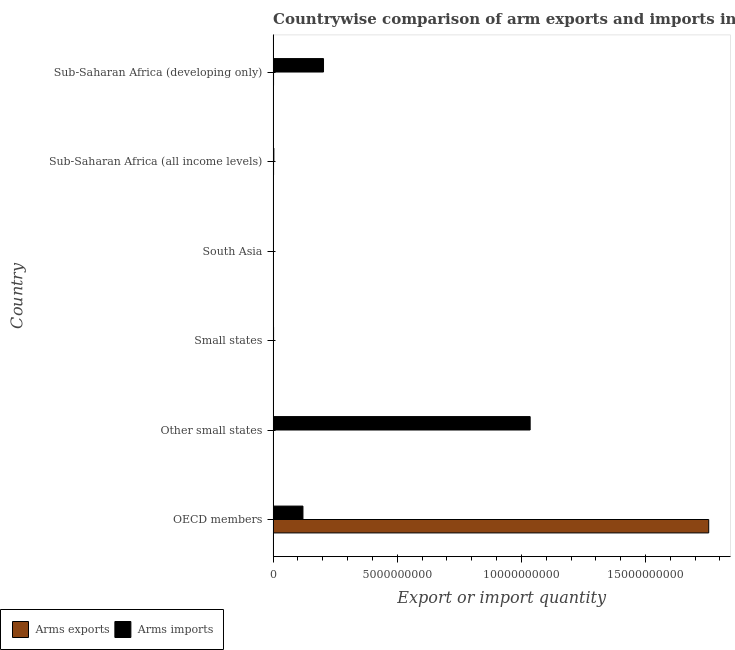How many groups of bars are there?
Your answer should be compact. 6. Are the number of bars per tick equal to the number of legend labels?
Your answer should be very brief. Yes. What is the label of the 1st group of bars from the top?
Make the answer very short. Sub-Saharan Africa (developing only). In how many cases, is the number of bars for a given country not equal to the number of legend labels?
Provide a short and direct response. 0. What is the arms exports in Sub-Saharan Africa (developing only)?
Your answer should be very brief. 1.70e+07. Across all countries, what is the maximum arms exports?
Ensure brevity in your answer.  1.75e+1. Across all countries, what is the minimum arms exports?
Offer a very short reply. 1.00e+06. In which country was the arms exports maximum?
Give a very brief answer. OECD members. In which country was the arms exports minimum?
Your response must be concise. Other small states. What is the total arms imports in the graph?
Offer a very short reply. 1.36e+1. What is the difference between the arms imports in Other small states and that in South Asia?
Your answer should be very brief. 1.03e+1. What is the difference between the arms imports in Small states and the arms exports in Other small states?
Your answer should be very brief. 1.70e+07. What is the average arms exports per country?
Offer a terse response. 2.93e+09. What is the difference between the arms imports and arms exports in Other small states?
Your answer should be compact. 1.04e+1. What is the ratio of the arms exports in South Asia to that in Sub-Saharan Africa (developing only)?
Keep it short and to the point. 0.12. What is the difference between the highest and the second highest arms exports?
Your response must be concise. 1.75e+1. What is the difference between the highest and the lowest arms exports?
Provide a short and direct response. 1.75e+1. In how many countries, is the arms imports greater than the average arms imports taken over all countries?
Offer a terse response. 1. Is the sum of the arms imports in Small states and South Asia greater than the maximum arms exports across all countries?
Offer a terse response. No. What does the 1st bar from the top in Small states represents?
Your response must be concise. Arms imports. What does the 1st bar from the bottom in OECD members represents?
Your response must be concise. Arms exports. How many bars are there?
Keep it short and to the point. 12. How many countries are there in the graph?
Keep it short and to the point. 6. Are the values on the major ticks of X-axis written in scientific E-notation?
Your answer should be very brief. No. What is the title of the graph?
Give a very brief answer. Countrywise comparison of arm exports and imports in 1995. Does "Merchandise imports" appear as one of the legend labels in the graph?
Make the answer very short. No. What is the label or title of the X-axis?
Offer a terse response. Export or import quantity. What is the label or title of the Y-axis?
Give a very brief answer. Country. What is the Export or import quantity in Arms exports in OECD members?
Your response must be concise. 1.75e+1. What is the Export or import quantity of Arms imports in OECD members?
Make the answer very short. 1.20e+09. What is the Export or import quantity in Arms imports in Other small states?
Your answer should be compact. 1.04e+1. What is the Export or import quantity of Arms imports in Small states?
Your answer should be very brief. 1.80e+07. What is the Export or import quantity in Arms imports in South Asia?
Your answer should be very brief. 1.20e+07. What is the Export or import quantity in Arms exports in Sub-Saharan Africa (all income levels)?
Ensure brevity in your answer.  1.80e+07. What is the Export or import quantity of Arms imports in Sub-Saharan Africa (all income levels)?
Provide a succinct answer. 3.00e+07. What is the Export or import quantity of Arms exports in Sub-Saharan Africa (developing only)?
Offer a terse response. 1.70e+07. What is the Export or import quantity of Arms imports in Sub-Saharan Africa (developing only)?
Your answer should be very brief. 2.03e+09. Across all countries, what is the maximum Export or import quantity in Arms exports?
Your answer should be very brief. 1.75e+1. Across all countries, what is the maximum Export or import quantity in Arms imports?
Your answer should be very brief. 1.04e+1. What is the total Export or import quantity of Arms exports in the graph?
Keep it short and to the point. 1.76e+1. What is the total Export or import quantity of Arms imports in the graph?
Your answer should be compact. 1.36e+1. What is the difference between the Export or import quantity in Arms exports in OECD members and that in Other small states?
Provide a short and direct response. 1.75e+1. What is the difference between the Export or import quantity of Arms imports in OECD members and that in Other small states?
Provide a succinct answer. -9.15e+09. What is the difference between the Export or import quantity in Arms exports in OECD members and that in Small states?
Your response must be concise. 1.75e+1. What is the difference between the Export or import quantity of Arms imports in OECD members and that in Small states?
Provide a short and direct response. 1.18e+09. What is the difference between the Export or import quantity of Arms exports in OECD members and that in South Asia?
Your answer should be very brief. 1.75e+1. What is the difference between the Export or import quantity in Arms imports in OECD members and that in South Asia?
Your response must be concise. 1.19e+09. What is the difference between the Export or import quantity of Arms exports in OECD members and that in Sub-Saharan Africa (all income levels)?
Keep it short and to the point. 1.75e+1. What is the difference between the Export or import quantity of Arms imports in OECD members and that in Sub-Saharan Africa (all income levels)?
Provide a succinct answer. 1.17e+09. What is the difference between the Export or import quantity in Arms exports in OECD members and that in Sub-Saharan Africa (developing only)?
Your response must be concise. 1.75e+1. What is the difference between the Export or import quantity of Arms imports in OECD members and that in Sub-Saharan Africa (developing only)?
Your response must be concise. -8.28e+08. What is the difference between the Export or import quantity in Arms imports in Other small states and that in Small states?
Keep it short and to the point. 1.03e+1. What is the difference between the Export or import quantity of Arms exports in Other small states and that in South Asia?
Your answer should be very brief. -1.00e+06. What is the difference between the Export or import quantity of Arms imports in Other small states and that in South Asia?
Make the answer very short. 1.03e+1. What is the difference between the Export or import quantity of Arms exports in Other small states and that in Sub-Saharan Africa (all income levels)?
Provide a short and direct response. -1.70e+07. What is the difference between the Export or import quantity in Arms imports in Other small states and that in Sub-Saharan Africa (all income levels)?
Your answer should be very brief. 1.03e+1. What is the difference between the Export or import quantity in Arms exports in Other small states and that in Sub-Saharan Africa (developing only)?
Offer a terse response. -1.60e+07. What is the difference between the Export or import quantity of Arms imports in Other small states and that in Sub-Saharan Africa (developing only)?
Provide a succinct answer. 8.32e+09. What is the difference between the Export or import quantity of Arms exports in Small states and that in South Asia?
Provide a short and direct response. -1.00e+06. What is the difference between the Export or import quantity in Arms exports in Small states and that in Sub-Saharan Africa (all income levels)?
Ensure brevity in your answer.  -1.70e+07. What is the difference between the Export or import quantity in Arms imports in Small states and that in Sub-Saharan Africa (all income levels)?
Make the answer very short. -1.20e+07. What is the difference between the Export or import quantity of Arms exports in Small states and that in Sub-Saharan Africa (developing only)?
Your answer should be very brief. -1.60e+07. What is the difference between the Export or import quantity of Arms imports in Small states and that in Sub-Saharan Africa (developing only)?
Give a very brief answer. -2.01e+09. What is the difference between the Export or import quantity in Arms exports in South Asia and that in Sub-Saharan Africa (all income levels)?
Ensure brevity in your answer.  -1.60e+07. What is the difference between the Export or import quantity of Arms imports in South Asia and that in Sub-Saharan Africa (all income levels)?
Your response must be concise. -1.80e+07. What is the difference between the Export or import quantity in Arms exports in South Asia and that in Sub-Saharan Africa (developing only)?
Offer a very short reply. -1.50e+07. What is the difference between the Export or import quantity of Arms imports in South Asia and that in Sub-Saharan Africa (developing only)?
Your answer should be very brief. -2.02e+09. What is the difference between the Export or import quantity of Arms exports in Sub-Saharan Africa (all income levels) and that in Sub-Saharan Africa (developing only)?
Ensure brevity in your answer.  1.00e+06. What is the difference between the Export or import quantity in Arms imports in Sub-Saharan Africa (all income levels) and that in Sub-Saharan Africa (developing only)?
Give a very brief answer. -2.00e+09. What is the difference between the Export or import quantity of Arms exports in OECD members and the Export or import quantity of Arms imports in Other small states?
Give a very brief answer. 7.19e+09. What is the difference between the Export or import quantity in Arms exports in OECD members and the Export or import quantity in Arms imports in Small states?
Make the answer very short. 1.75e+1. What is the difference between the Export or import quantity in Arms exports in OECD members and the Export or import quantity in Arms imports in South Asia?
Make the answer very short. 1.75e+1. What is the difference between the Export or import quantity of Arms exports in OECD members and the Export or import quantity of Arms imports in Sub-Saharan Africa (all income levels)?
Offer a terse response. 1.75e+1. What is the difference between the Export or import quantity of Arms exports in OECD members and the Export or import quantity of Arms imports in Sub-Saharan Africa (developing only)?
Your response must be concise. 1.55e+1. What is the difference between the Export or import quantity of Arms exports in Other small states and the Export or import quantity of Arms imports in Small states?
Provide a succinct answer. -1.70e+07. What is the difference between the Export or import quantity in Arms exports in Other small states and the Export or import quantity in Arms imports in South Asia?
Provide a succinct answer. -1.10e+07. What is the difference between the Export or import quantity of Arms exports in Other small states and the Export or import quantity of Arms imports in Sub-Saharan Africa (all income levels)?
Make the answer very short. -2.90e+07. What is the difference between the Export or import quantity of Arms exports in Other small states and the Export or import quantity of Arms imports in Sub-Saharan Africa (developing only)?
Provide a short and direct response. -2.03e+09. What is the difference between the Export or import quantity in Arms exports in Small states and the Export or import quantity in Arms imports in South Asia?
Your answer should be very brief. -1.10e+07. What is the difference between the Export or import quantity in Arms exports in Small states and the Export or import quantity in Arms imports in Sub-Saharan Africa (all income levels)?
Make the answer very short. -2.90e+07. What is the difference between the Export or import quantity of Arms exports in Small states and the Export or import quantity of Arms imports in Sub-Saharan Africa (developing only)?
Ensure brevity in your answer.  -2.03e+09. What is the difference between the Export or import quantity in Arms exports in South Asia and the Export or import quantity in Arms imports in Sub-Saharan Africa (all income levels)?
Offer a very short reply. -2.80e+07. What is the difference between the Export or import quantity in Arms exports in South Asia and the Export or import quantity in Arms imports in Sub-Saharan Africa (developing only)?
Offer a terse response. -2.03e+09. What is the difference between the Export or import quantity in Arms exports in Sub-Saharan Africa (all income levels) and the Export or import quantity in Arms imports in Sub-Saharan Africa (developing only)?
Keep it short and to the point. -2.01e+09. What is the average Export or import quantity in Arms exports per country?
Provide a succinct answer. 2.93e+09. What is the average Export or import quantity in Arms imports per country?
Your answer should be compact. 2.27e+09. What is the difference between the Export or import quantity of Arms exports and Export or import quantity of Arms imports in OECD members?
Your answer should be very brief. 1.63e+1. What is the difference between the Export or import quantity in Arms exports and Export or import quantity in Arms imports in Other small states?
Make the answer very short. -1.04e+1. What is the difference between the Export or import quantity in Arms exports and Export or import quantity in Arms imports in Small states?
Offer a terse response. -1.70e+07. What is the difference between the Export or import quantity of Arms exports and Export or import quantity of Arms imports in South Asia?
Your answer should be compact. -1.00e+07. What is the difference between the Export or import quantity in Arms exports and Export or import quantity in Arms imports in Sub-Saharan Africa (all income levels)?
Ensure brevity in your answer.  -1.20e+07. What is the difference between the Export or import quantity of Arms exports and Export or import quantity of Arms imports in Sub-Saharan Africa (developing only)?
Your response must be concise. -2.01e+09. What is the ratio of the Export or import quantity in Arms exports in OECD members to that in Other small states?
Your answer should be compact. 1.75e+04. What is the ratio of the Export or import quantity in Arms imports in OECD members to that in Other small states?
Your response must be concise. 0.12. What is the ratio of the Export or import quantity of Arms exports in OECD members to that in Small states?
Make the answer very short. 1.75e+04. What is the ratio of the Export or import quantity in Arms imports in OECD members to that in Small states?
Make the answer very short. 66.78. What is the ratio of the Export or import quantity of Arms exports in OECD members to that in South Asia?
Offer a terse response. 8773.5. What is the ratio of the Export or import quantity in Arms imports in OECD members to that in South Asia?
Ensure brevity in your answer.  100.17. What is the ratio of the Export or import quantity of Arms exports in OECD members to that in Sub-Saharan Africa (all income levels)?
Offer a terse response. 974.83. What is the ratio of the Export or import quantity of Arms imports in OECD members to that in Sub-Saharan Africa (all income levels)?
Make the answer very short. 40.07. What is the ratio of the Export or import quantity of Arms exports in OECD members to that in Sub-Saharan Africa (developing only)?
Make the answer very short. 1032.18. What is the ratio of the Export or import quantity of Arms imports in OECD members to that in Sub-Saharan Africa (developing only)?
Give a very brief answer. 0.59. What is the ratio of the Export or import quantity in Arms exports in Other small states to that in Small states?
Give a very brief answer. 1. What is the ratio of the Export or import quantity in Arms imports in Other small states to that in Small states?
Your answer should be very brief. 575.22. What is the ratio of the Export or import quantity of Arms exports in Other small states to that in South Asia?
Provide a succinct answer. 0.5. What is the ratio of the Export or import quantity of Arms imports in Other small states to that in South Asia?
Make the answer very short. 862.83. What is the ratio of the Export or import quantity of Arms exports in Other small states to that in Sub-Saharan Africa (all income levels)?
Offer a very short reply. 0.06. What is the ratio of the Export or import quantity of Arms imports in Other small states to that in Sub-Saharan Africa (all income levels)?
Keep it short and to the point. 345.13. What is the ratio of the Export or import quantity of Arms exports in Other small states to that in Sub-Saharan Africa (developing only)?
Make the answer very short. 0.06. What is the ratio of the Export or import quantity of Arms imports in Other small states to that in Sub-Saharan Africa (developing only)?
Give a very brief answer. 5.1. What is the ratio of the Export or import quantity of Arms exports in Small states to that in South Asia?
Provide a short and direct response. 0.5. What is the ratio of the Export or import quantity in Arms imports in Small states to that in South Asia?
Offer a terse response. 1.5. What is the ratio of the Export or import quantity in Arms exports in Small states to that in Sub-Saharan Africa (all income levels)?
Provide a short and direct response. 0.06. What is the ratio of the Export or import quantity in Arms imports in Small states to that in Sub-Saharan Africa (all income levels)?
Your answer should be compact. 0.6. What is the ratio of the Export or import quantity in Arms exports in Small states to that in Sub-Saharan Africa (developing only)?
Offer a very short reply. 0.06. What is the ratio of the Export or import quantity of Arms imports in Small states to that in Sub-Saharan Africa (developing only)?
Make the answer very short. 0.01. What is the ratio of the Export or import quantity in Arms exports in South Asia to that in Sub-Saharan Africa (developing only)?
Provide a short and direct response. 0.12. What is the ratio of the Export or import quantity of Arms imports in South Asia to that in Sub-Saharan Africa (developing only)?
Ensure brevity in your answer.  0.01. What is the ratio of the Export or import quantity in Arms exports in Sub-Saharan Africa (all income levels) to that in Sub-Saharan Africa (developing only)?
Keep it short and to the point. 1.06. What is the ratio of the Export or import quantity in Arms imports in Sub-Saharan Africa (all income levels) to that in Sub-Saharan Africa (developing only)?
Make the answer very short. 0.01. What is the difference between the highest and the second highest Export or import quantity of Arms exports?
Give a very brief answer. 1.75e+1. What is the difference between the highest and the second highest Export or import quantity of Arms imports?
Provide a short and direct response. 8.32e+09. What is the difference between the highest and the lowest Export or import quantity of Arms exports?
Your response must be concise. 1.75e+1. What is the difference between the highest and the lowest Export or import quantity of Arms imports?
Provide a short and direct response. 1.03e+1. 